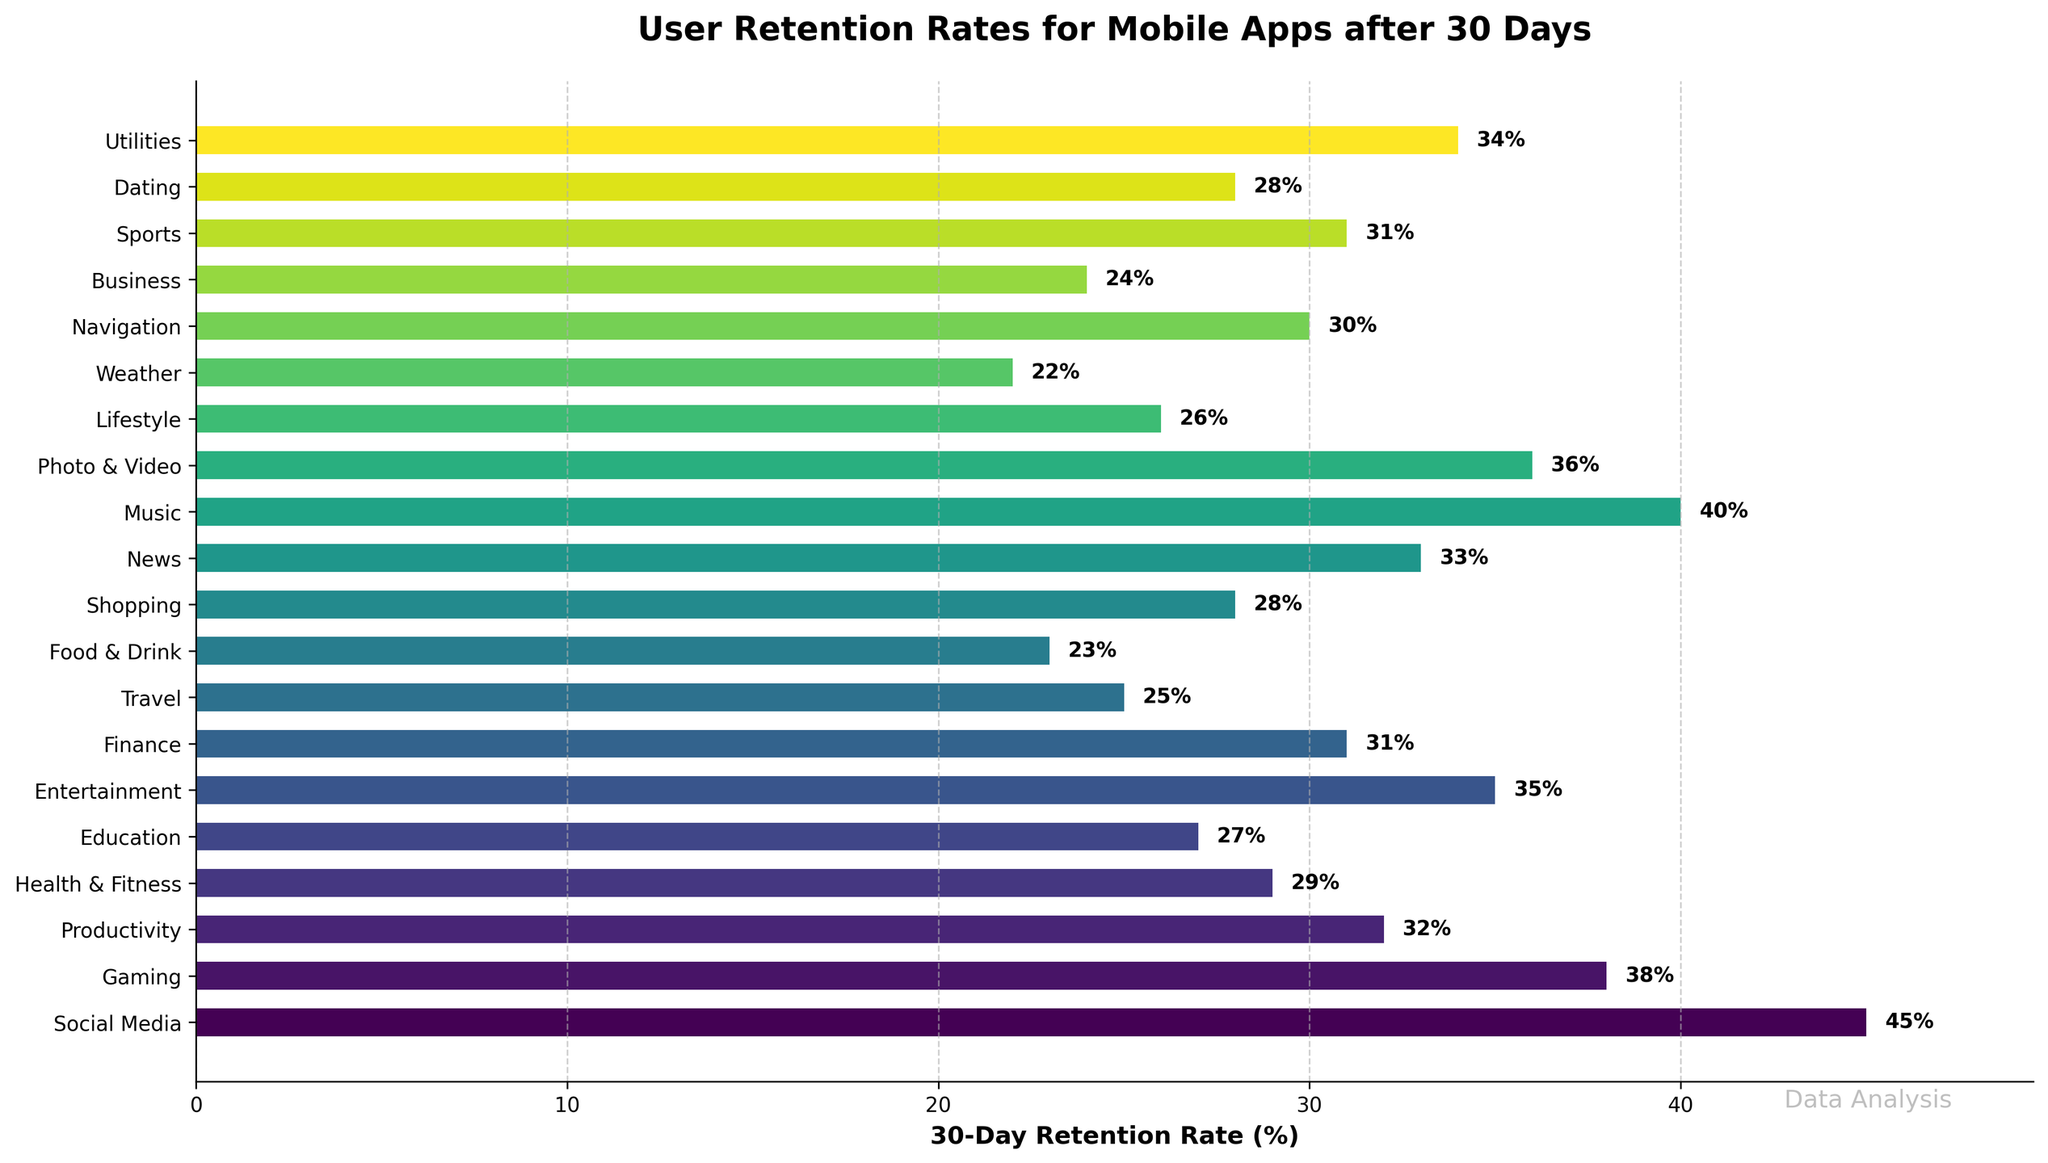What is the highest 30-day retention rate among all the app types? The highest bar represents the highest retention rate. In this case, the "Social Media" bar reaches the highest value, which is 45%.
Answer: 45% Which app type has the lowest 30-day retention rate? The shortest bar represents the lowest retention rate. The "Weather" app has the shortest bar, indicating a 22% retention rate.
Answer: Weather How much higher is the retention rate for Social Media apps compared to Travel apps? The retention rate for Social Media apps is 45%, and for Travel apps, it is 25%. The difference is 45% - 25% = 20%.
Answer: 20% What is the average 30-day retention rate of Productivity, Finance, and Navigation apps? The retention rates for these apps are: Productivity (32%), Finance (31%), and Navigation (30%). The average is calculated as (32 + 31 + 30) / 3 = 31%.
Answer: 31% Is the 30-day retention rate for Entertainment apps higher or lower than News apps? The bar for Entertainment apps is 35%, and the bar for News apps is 33%. Since 35% is higher than 33%, Entertainment apps have a higher retention rate.
Answer: Higher Are there any app types with exactly the same 30-day retention rate? If yes, which ones? By examining the bars, both Sports and Finance apps have a 31% retention rate.
Answer: Sports and Finance Among Music, Photo & Video, and Utilities apps, which has the highest 30-day retention rate? The retention rates are: Music (40%), Photo & Video (36%), and Utilities (34%). The highest value is for Music apps.
Answer: Music What is the total retention rate if you add up Gaming, Health & Fitness, and Food & Drink apps? The retention rates are: Gaming (38%), Health & Fitness (29%), and Food & Drink (23%). The sum is 38% + 29% + 23% = 90%.
Answer: 90% What is the median 30-day retention rate for all the app types? To find the median, the retention rates must be sorted: 22, 23, 24, 25, 26, 27, 28, 28, 29, 30, 31, 31, 32, 33, 34, 35, 36, 38, 40, 45. The median of 20 values is the average of the 10th and 11th values, (30 + 31) / 2 = 30.5%.
Answer: 30.5% Which app type has a 30-day retention rate closest to the average 30-day retention rate of all app types? The average retention rate is calculated as the sum of all retention rates divided by the number of app types: (45 + 38 + 32 + 29 + 27 + 35 + 31 + 25 + 23 + 28 + 33 + 40 + 36 + 26 + 22 + 30 + 24 + 31 + 28 + 34) / 20 = 31.05%. The closest is either Finance or Sports which have 31%.
Answer: Finance or Sports 